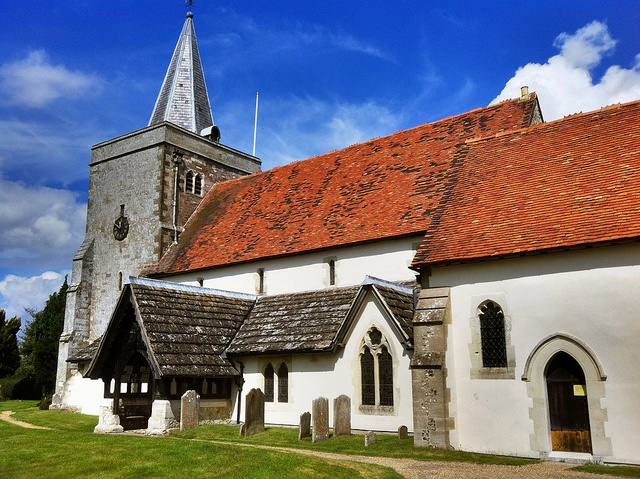Describe the objects in this image and their specific colors. I can see a clock in blue, black, darkgreen, and gray tones in this image. 